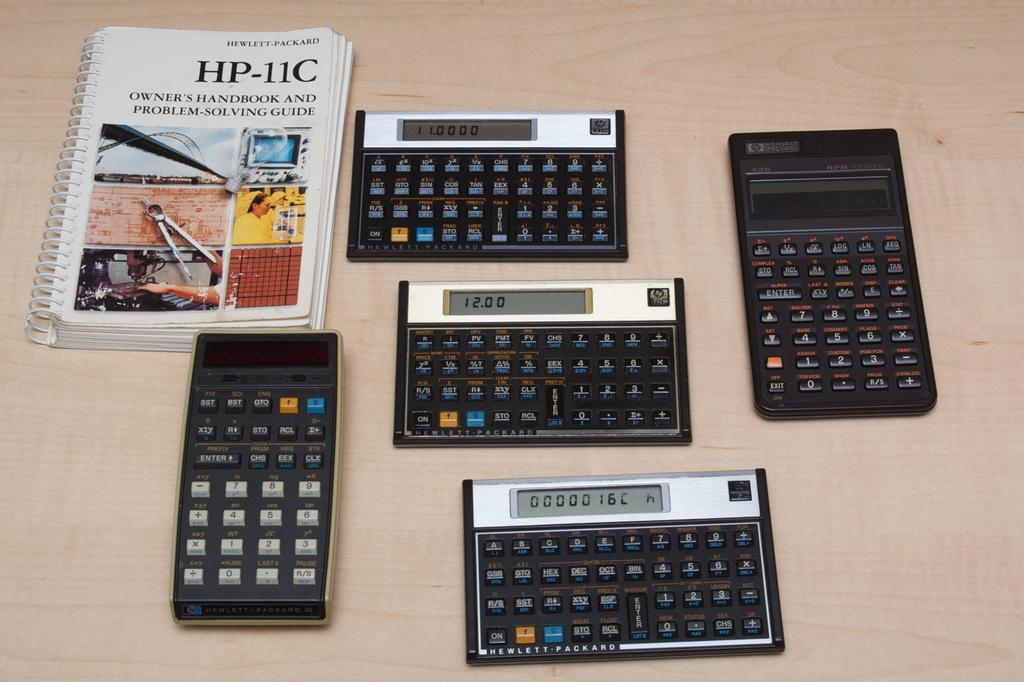<image>
Give a short and clear explanation of the subsequent image. the letter HP is on the front of the book 